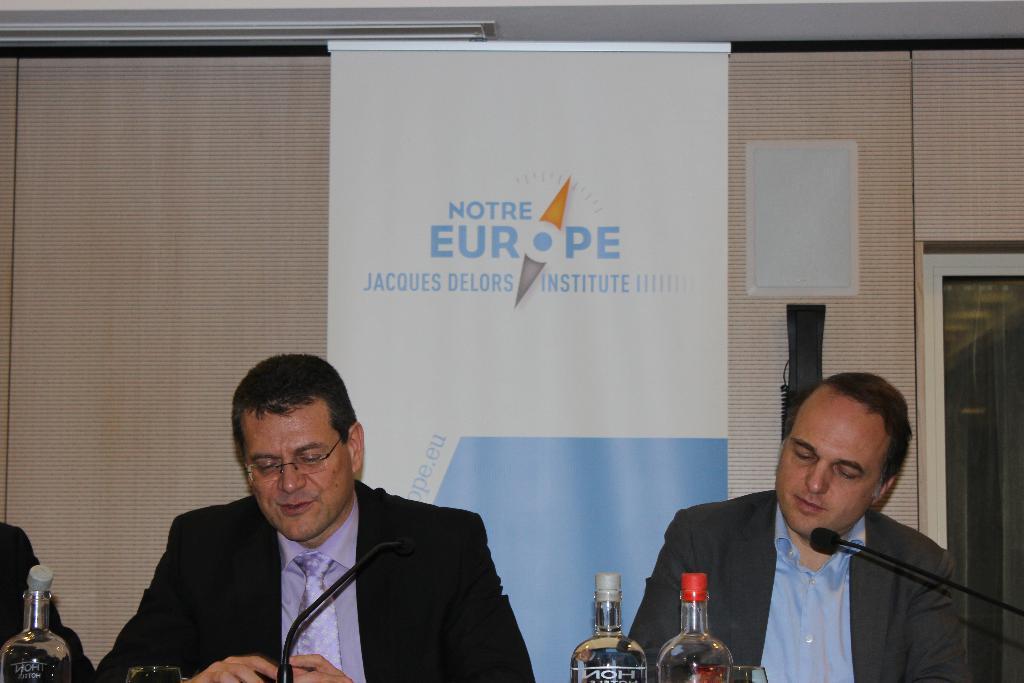Can you describe this image briefly? In this image, There are some people sitting on the chairs there are some microphones which are in black color, There are some bottles, in the background there is a yellow color curtain, In the middle there is a white color poster. 